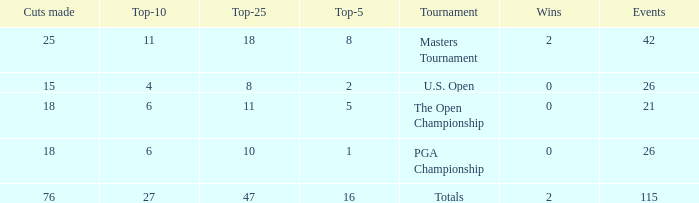When the wins are less than 0 and the Top-5 1 what is the average cuts? None. 